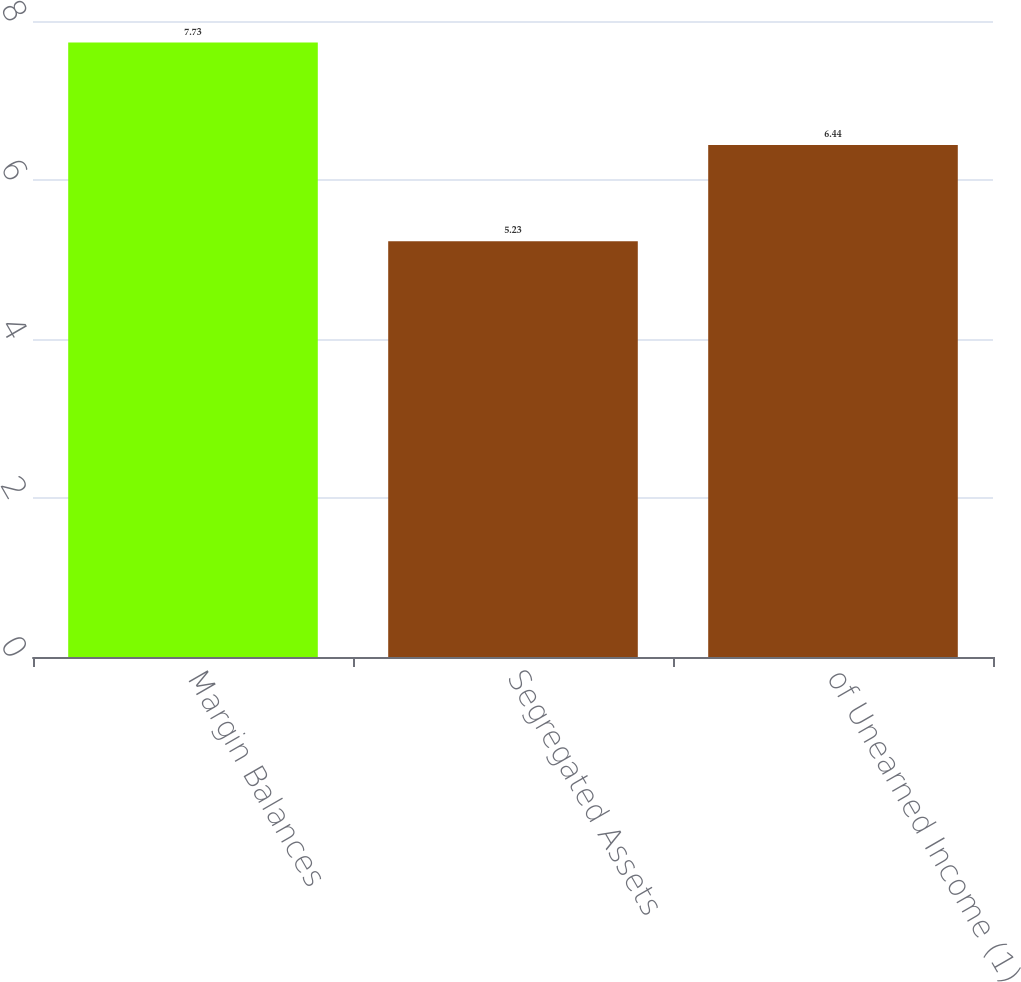Convert chart to OTSL. <chart><loc_0><loc_0><loc_500><loc_500><bar_chart><fcel>Margin Balances<fcel>Segregated Assets<fcel>of Unearned Income (1)<nl><fcel>7.73<fcel>5.23<fcel>6.44<nl></chart> 